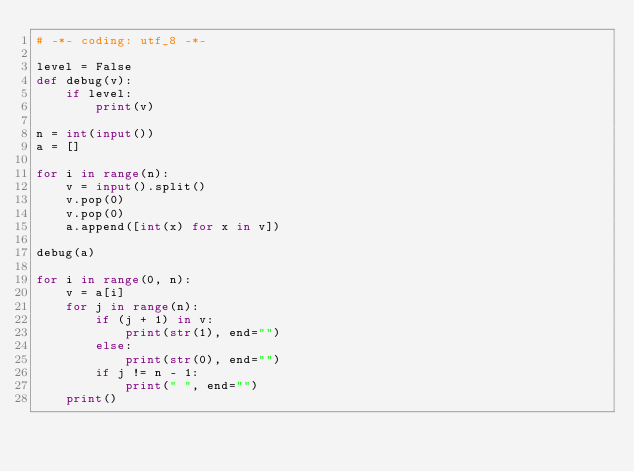<code> <loc_0><loc_0><loc_500><loc_500><_Python_># -*- coding: utf_8 -*-

level = False
def debug(v):
    if level:
        print(v)

n = int(input())
a = []

for i in range(n):
    v = input().split()
    v.pop(0)
    v.pop(0)
    a.append([int(x) for x in v])

debug(a)

for i in range(0, n):
    v = a[i]
    for j in range(n):
        if (j + 1) in v:
            print(str(1), end="")
        else:
            print(str(0), end="")
        if j != n - 1:
            print(" ", end="")
    print()</code> 